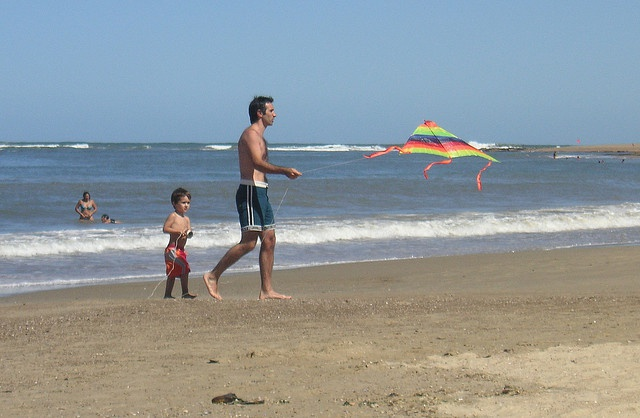Describe the objects in this image and their specific colors. I can see people in lightblue, gray, and black tones, people in lightblue, maroon, black, and gray tones, kite in lightblue, salmon, gray, and khaki tones, people in lightblue, gray, and black tones, and people in lightblue, gray, and darkgray tones in this image. 